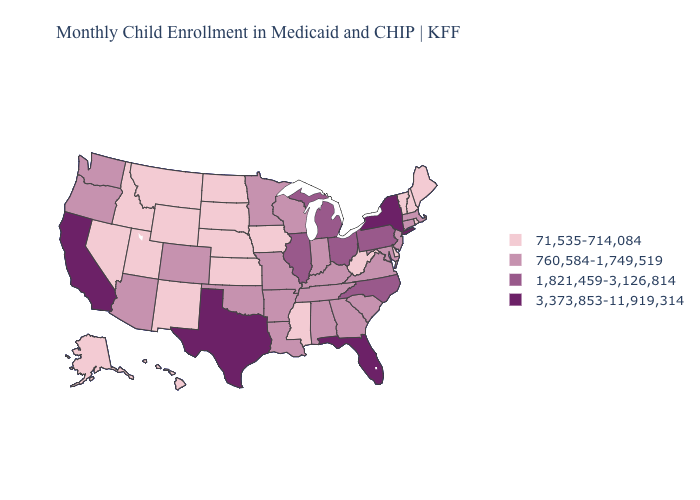Does Delaware have the highest value in the USA?
Keep it brief. No. Does Illinois have the same value as Mississippi?
Answer briefly. No. Name the states that have a value in the range 71,535-714,084?
Concise answer only. Alaska, Delaware, Hawaii, Idaho, Iowa, Kansas, Maine, Mississippi, Montana, Nebraska, Nevada, New Hampshire, New Mexico, North Dakota, Rhode Island, South Dakota, Utah, Vermont, West Virginia, Wyoming. Among the states that border Indiana , does Ohio have the highest value?
Short answer required. Yes. Does Washington have a higher value than Idaho?
Write a very short answer. Yes. What is the highest value in the South ?
Short answer required. 3,373,853-11,919,314. Name the states that have a value in the range 760,584-1,749,519?
Concise answer only. Alabama, Arizona, Arkansas, Colorado, Connecticut, Georgia, Indiana, Kentucky, Louisiana, Maryland, Massachusetts, Minnesota, Missouri, New Jersey, Oklahoma, Oregon, South Carolina, Tennessee, Virginia, Washington, Wisconsin. Does Florida have a higher value than Texas?
Give a very brief answer. No. Among the states that border Oregon , which have the highest value?
Give a very brief answer. California. Which states have the highest value in the USA?
Short answer required. California, Florida, New York, Texas. Name the states that have a value in the range 71,535-714,084?
Quick response, please. Alaska, Delaware, Hawaii, Idaho, Iowa, Kansas, Maine, Mississippi, Montana, Nebraska, Nevada, New Hampshire, New Mexico, North Dakota, Rhode Island, South Dakota, Utah, Vermont, West Virginia, Wyoming. What is the lowest value in the USA?
Short answer required. 71,535-714,084. Among the states that border Arkansas , does Mississippi have the lowest value?
Answer briefly. Yes. Which states have the highest value in the USA?
Be succinct. California, Florida, New York, Texas. 